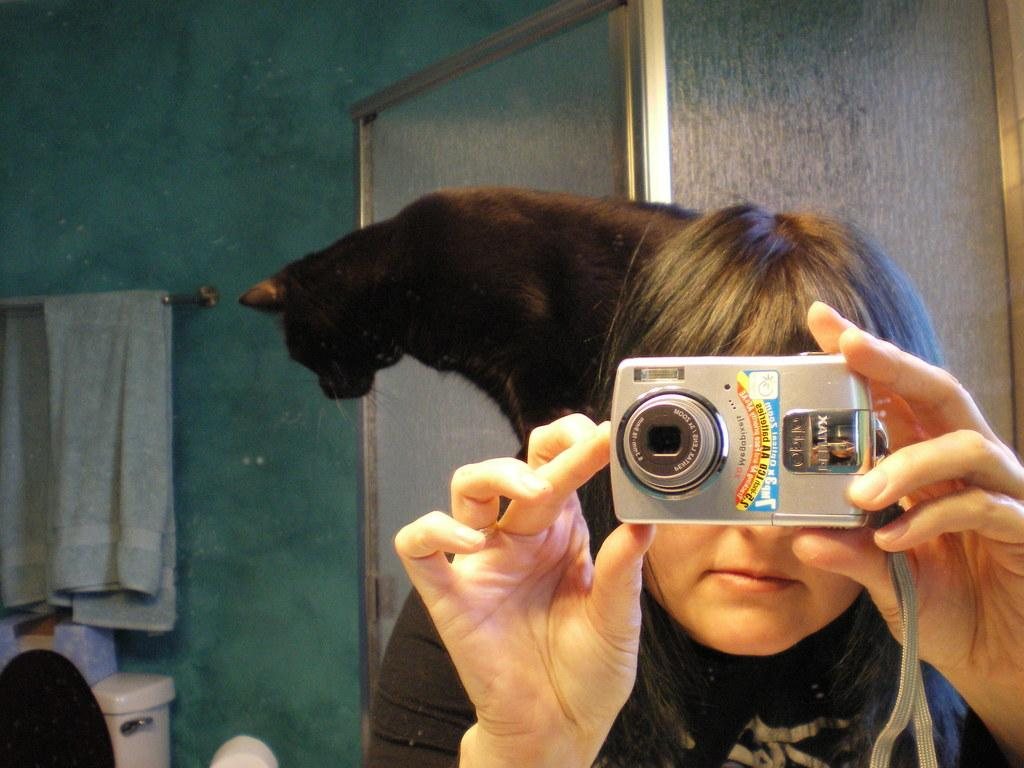Who is the main subject in the image? There is a girl in the image. What is the girl holding in the image? The girl is holding a camera. Can you describe the animal behind the girl? There is a cat behind the girl. What is hanging on the hanger in the image? A towel is hanging on the hanger. What type of toy can be seen being played with by the girl in the image? There is no toy visible in the image; the girl is holding a camera. What show is the girl watching on the hanger in the image? There is no show being watched in the image; a towel is hanging on the hanger. 